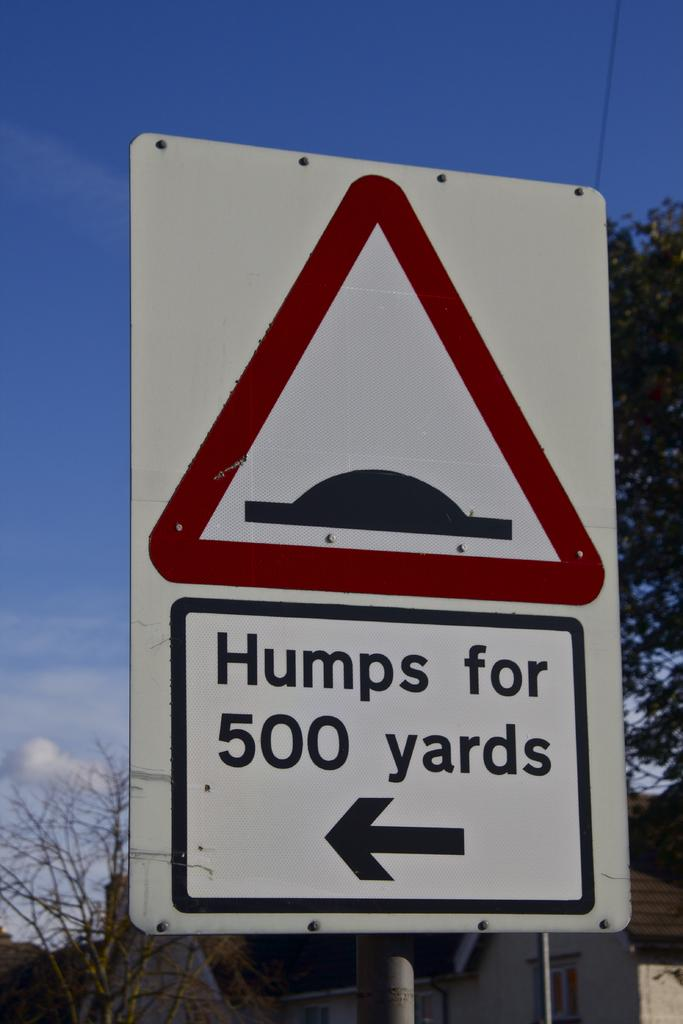<image>
Present a compact description of the photo's key features. A red triangle sign is above the wording Humps for 500 yards set against a clear blue sky. 